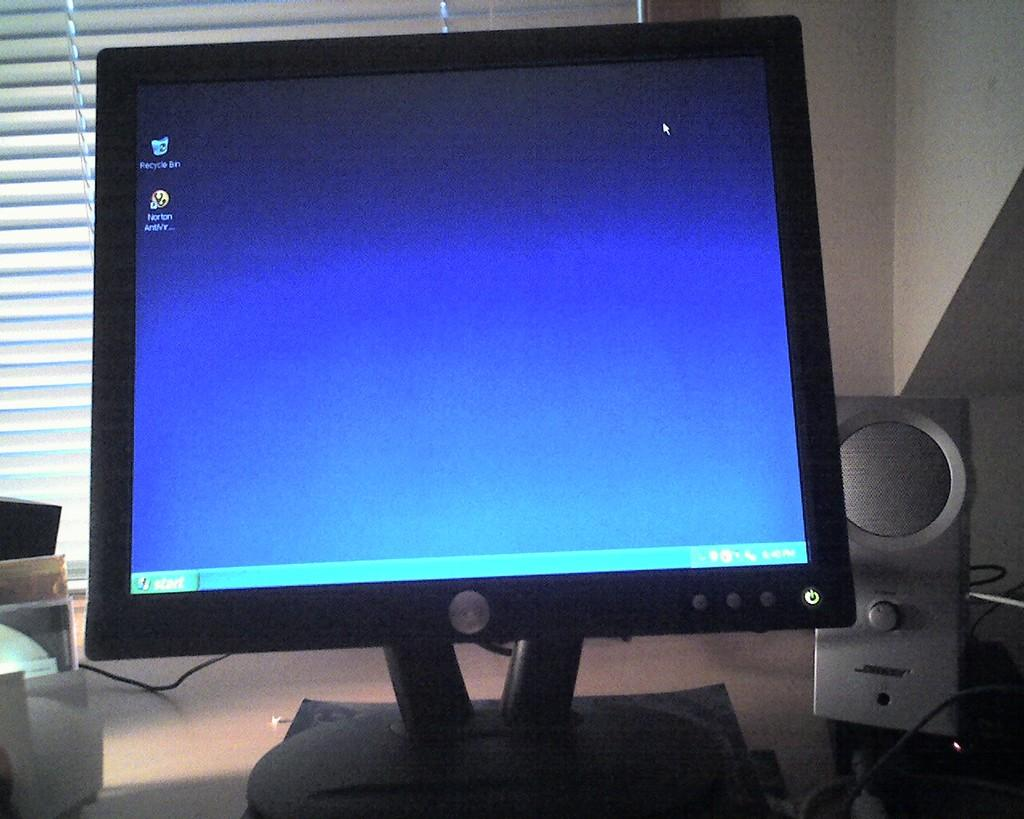What is the main object in the image? There is a desktop in the image. What is located beside the desktop? There is a speaker beside the desktop. What can be seen in the background of the image? There is a curtain in the background of the image. What type of storage device is visible on the left side of the image? There are CDs on the left side of the image. What type of expert is sitting on the edge of the desktop in the image? There is no expert sitting on the edge of the desktop in the image; the desktop is a piece of furniture and not a location for a person to sit. 